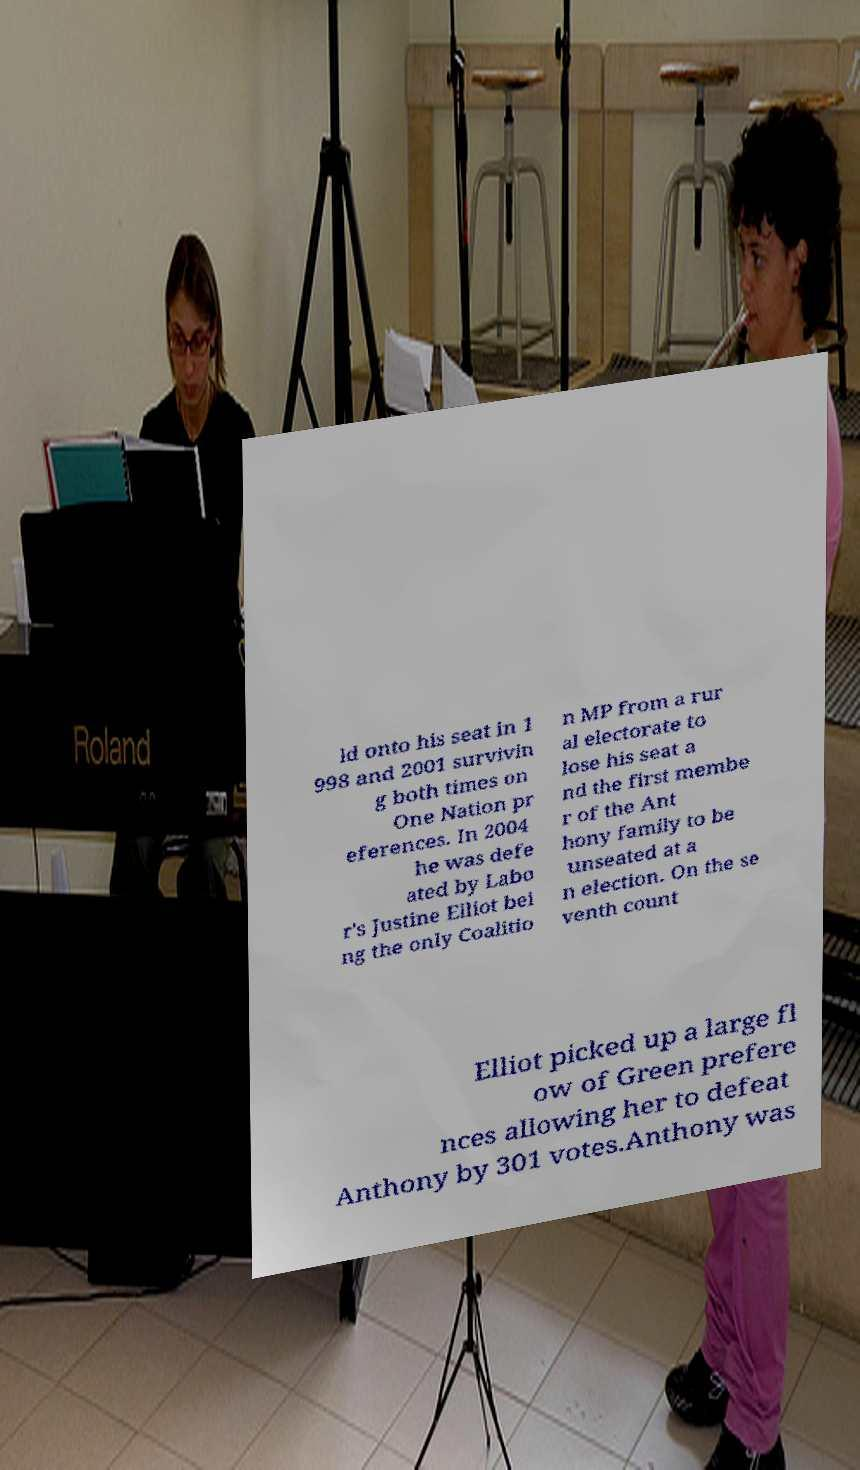Please read and relay the text visible in this image. What does it say? ld onto his seat in 1 998 and 2001 survivin g both times on One Nation pr eferences. In 2004 he was defe ated by Labo r's Justine Elliot bei ng the only Coalitio n MP from a rur al electorate to lose his seat a nd the first membe r of the Ant hony family to be unseated at a n election. On the se venth count Elliot picked up a large fl ow of Green prefere nces allowing her to defeat Anthony by 301 votes.Anthony was 